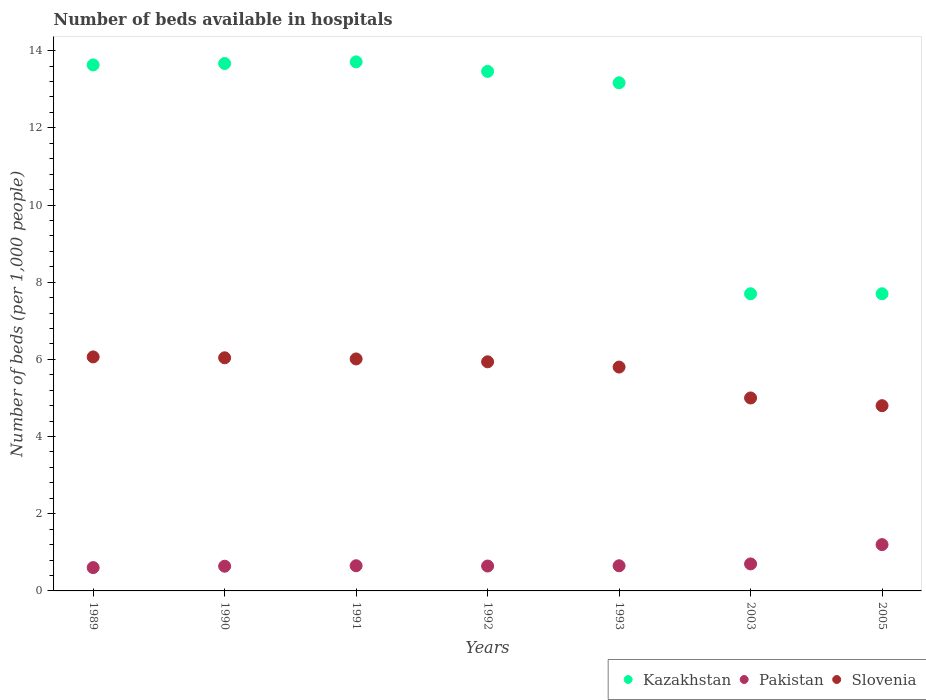How many different coloured dotlines are there?
Your answer should be very brief. 3. What is the number of beds in the hospiatls of in Slovenia in 1990?
Offer a terse response. 6.04. Across all years, what is the minimum number of beds in the hospiatls of in Pakistan?
Make the answer very short. 0.6. What is the total number of beds in the hospiatls of in Pakistan in the graph?
Offer a very short reply. 5.09. What is the difference between the number of beds in the hospiatls of in Pakistan in 1991 and that in 1993?
Your answer should be very brief. 0. What is the difference between the number of beds in the hospiatls of in Kazakhstan in 1993 and the number of beds in the hospiatls of in Pakistan in 2003?
Your answer should be compact. 12.47. What is the average number of beds in the hospiatls of in Slovenia per year?
Provide a short and direct response. 5.66. In the year 2005, what is the difference between the number of beds in the hospiatls of in Slovenia and number of beds in the hospiatls of in Kazakhstan?
Your response must be concise. -2.9. What is the ratio of the number of beds in the hospiatls of in Slovenia in 1990 to that in 1992?
Ensure brevity in your answer.  1.02. Is the difference between the number of beds in the hospiatls of in Slovenia in 1993 and 2005 greater than the difference between the number of beds in the hospiatls of in Kazakhstan in 1993 and 2005?
Ensure brevity in your answer.  No. What is the difference between the highest and the lowest number of beds in the hospiatls of in Slovenia?
Keep it short and to the point. 1.26. In how many years, is the number of beds in the hospiatls of in Kazakhstan greater than the average number of beds in the hospiatls of in Kazakhstan taken over all years?
Give a very brief answer. 5. Is it the case that in every year, the sum of the number of beds in the hospiatls of in Kazakhstan and number of beds in the hospiatls of in Pakistan  is greater than the number of beds in the hospiatls of in Slovenia?
Provide a succinct answer. Yes. Does the number of beds in the hospiatls of in Kazakhstan monotonically increase over the years?
Your answer should be compact. No. Is the number of beds in the hospiatls of in Kazakhstan strictly less than the number of beds in the hospiatls of in Pakistan over the years?
Your answer should be very brief. No. How many dotlines are there?
Offer a very short reply. 3. How many years are there in the graph?
Ensure brevity in your answer.  7. What is the difference between two consecutive major ticks on the Y-axis?
Offer a very short reply. 2. Are the values on the major ticks of Y-axis written in scientific E-notation?
Keep it short and to the point. No. Does the graph contain any zero values?
Your answer should be very brief. No. How are the legend labels stacked?
Make the answer very short. Horizontal. What is the title of the graph?
Make the answer very short. Number of beds available in hospitals. What is the label or title of the X-axis?
Offer a very short reply. Years. What is the label or title of the Y-axis?
Your answer should be very brief. Number of beds (per 1,0 people). What is the Number of beds (per 1,000 people) of Kazakhstan in 1989?
Provide a short and direct response. 13.63. What is the Number of beds (per 1,000 people) of Pakistan in 1989?
Your answer should be very brief. 0.6. What is the Number of beds (per 1,000 people) in Slovenia in 1989?
Provide a short and direct response. 6.06. What is the Number of beds (per 1,000 people) of Kazakhstan in 1990?
Give a very brief answer. 13.67. What is the Number of beds (per 1,000 people) of Pakistan in 1990?
Provide a succinct answer. 0.64. What is the Number of beds (per 1,000 people) of Slovenia in 1990?
Your answer should be very brief. 6.04. What is the Number of beds (per 1,000 people) in Kazakhstan in 1991?
Your answer should be very brief. 13.71. What is the Number of beds (per 1,000 people) of Pakistan in 1991?
Your answer should be very brief. 0.65. What is the Number of beds (per 1,000 people) in Slovenia in 1991?
Your answer should be very brief. 6.01. What is the Number of beds (per 1,000 people) in Kazakhstan in 1992?
Your response must be concise. 13.46. What is the Number of beds (per 1,000 people) in Pakistan in 1992?
Offer a very short reply. 0.64. What is the Number of beds (per 1,000 people) of Slovenia in 1992?
Keep it short and to the point. 5.94. What is the Number of beds (per 1,000 people) in Kazakhstan in 1993?
Provide a short and direct response. 13.17. What is the Number of beds (per 1,000 people) in Pakistan in 1993?
Your answer should be compact. 0.65. What is the Number of beds (per 1,000 people) in Slovenia in 1993?
Your answer should be compact. 5.8. What is the Number of beds (per 1,000 people) of Kazakhstan in 2003?
Your response must be concise. 7.7. Across all years, what is the maximum Number of beds (per 1,000 people) in Kazakhstan?
Offer a very short reply. 13.71. Across all years, what is the maximum Number of beds (per 1,000 people) in Slovenia?
Ensure brevity in your answer.  6.06. Across all years, what is the minimum Number of beds (per 1,000 people) of Kazakhstan?
Offer a terse response. 7.7. Across all years, what is the minimum Number of beds (per 1,000 people) of Pakistan?
Provide a short and direct response. 0.6. Across all years, what is the minimum Number of beds (per 1,000 people) in Slovenia?
Offer a terse response. 4.8. What is the total Number of beds (per 1,000 people) of Kazakhstan in the graph?
Keep it short and to the point. 83.03. What is the total Number of beds (per 1,000 people) of Pakistan in the graph?
Your answer should be compact. 5.09. What is the total Number of beds (per 1,000 people) of Slovenia in the graph?
Your answer should be very brief. 39.65. What is the difference between the Number of beds (per 1,000 people) in Kazakhstan in 1989 and that in 1990?
Keep it short and to the point. -0.04. What is the difference between the Number of beds (per 1,000 people) of Pakistan in 1989 and that in 1990?
Keep it short and to the point. -0.04. What is the difference between the Number of beds (per 1,000 people) of Slovenia in 1989 and that in 1990?
Provide a succinct answer. 0.02. What is the difference between the Number of beds (per 1,000 people) in Kazakhstan in 1989 and that in 1991?
Provide a succinct answer. -0.08. What is the difference between the Number of beds (per 1,000 people) in Pakistan in 1989 and that in 1991?
Provide a succinct answer. -0.05. What is the difference between the Number of beds (per 1,000 people) in Slovenia in 1989 and that in 1991?
Your answer should be very brief. 0.05. What is the difference between the Number of beds (per 1,000 people) of Kazakhstan in 1989 and that in 1992?
Offer a very short reply. 0.17. What is the difference between the Number of beds (per 1,000 people) in Pakistan in 1989 and that in 1992?
Your answer should be very brief. -0.04. What is the difference between the Number of beds (per 1,000 people) in Slovenia in 1989 and that in 1992?
Give a very brief answer. 0.13. What is the difference between the Number of beds (per 1,000 people) in Kazakhstan in 1989 and that in 1993?
Keep it short and to the point. 0.46. What is the difference between the Number of beds (per 1,000 people) of Pakistan in 1989 and that in 1993?
Your answer should be compact. -0.05. What is the difference between the Number of beds (per 1,000 people) of Slovenia in 1989 and that in 1993?
Provide a short and direct response. 0.26. What is the difference between the Number of beds (per 1,000 people) of Kazakhstan in 1989 and that in 2003?
Make the answer very short. 5.93. What is the difference between the Number of beds (per 1,000 people) in Pakistan in 1989 and that in 2003?
Offer a terse response. -0.1. What is the difference between the Number of beds (per 1,000 people) of Slovenia in 1989 and that in 2003?
Your answer should be compact. 1.06. What is the difference between the Number of beds (per 1,000 people) of Kazakhstan in 1989 and that in 2005?
Provide a succinct answer. 5.93. What is the difference between the Number of beds (per 1,000 people) in Pakistan in 1989 and that in 2005?
Your response must be concise. -0.6. What is the difference between the Number of beds (per 1,000 people) of Slovenia in 1989 and that in 2005?
Provide a succinct answer. 1.26. What is the difference between the Number of beds (per 1,000 people) of Kazakhstan in 1990 and that in 1991?
Make the answer very short. -0.04. What is the difference between the Number of beds (per 1,000 people) of Pakistan in 1990 and that in 1991?
Ensure brevity in your answer.  -0.01. What is the difference between the Number of beds (per 1,000 people) in Slovenia in 1990 and that in 1991?
Make the answer very short. 0.03. What is the difference between the Number of beds (per 1,000 people) in Kazakhstan in 1990 and that in 1992?
Keep it short and to the point. 0.2. What is the difference between the Number of beds (per 1,000 people) of Pakistan in 1990 and that in 1992?
Ensure brevity in your answer.  -0. What is the difference between the Number of beds (per 1,000 people) in Slovenia in 1990 and that in 1992?
Offer a terse response. 0.1. What is the difference between the Number of beds (per 1,000 people) of Kazakhstan in 1990 and that in 1993?
Offer a terse response. 0.5. What is the difference between the Number of beds (per 1,000 people) of Pakistan in 1990 and that in 1993?
Your answer should be very brief. -0.01. What is the difference between the Number of beds (per 1,000 people) of Slovenia in 1990 and that in 1993?
Offer a terse response. 0.24. What is the difference between the Number of beds (per 1,000 people) of Kazakhstan in 1990 and that in 2003?
Ensure brevity in your answer.  5.97. What is the difference between the Number of beds (per 1,000 people) of Pakistan in 1990 and that in 2003?
Your answer should be very brief. -0.06. What is the difference between the Number of beds (per 1,000 people) of Slovenia in 1990 and that in 2003?
Give a very brief answer. 1.04. What is the difference between the Number of beds (per 1,000 people) in Kazakhstan in 1990 and that in 2005?
Your answer should be very brief. 5.97. What is the difference between the Number of beds (per 1,000 people) in Pakistan in 1990 and that in 2005?
Your answer should be compact. -0.56. What is the difference between the Number of beds (per 1,000 people) in Slovenia in 1990 and that in 2005?
Give a very brief answer. 1.24. What is the difference between the Number of beds (per 1,000 people) in Kazakhstan in 1991 and that in 1992?
Offer a terse response. 0.25. What is the difference between the Number of beds (per 1,000 people) of Pakistan in 1991 and that in 1992?
Your answer should be very brief. 0.01. What is the difference between the Number of beds (per 1,000 people) in Slovenia in 1991 and that in 1992?
Make the answer very short. 0.07. What is the difference between the Number of beds (per 1,000 people) in Kazakhstan in 1991 and that in 1993?
Offer a very short reply. 0.54. What is the difference between the Number of beds (per 1,000 people) of Pakistan in 1991 and that in 1993?
Offer a very short reply. 0. What is the difference between the Number of beds (per 1,000 people) in Slovenia in 1991 and that in 1993?
Your answer should be compact. 0.21. What is the difference between the Number of beds (per 1,000 people) in Kazakhstan in 1991 and that in 2003?
Give a very brief answer. 6.01. What is the difference between the Number of beds (per 1,000 people) of Pakistan in 1991 and that in 2003?
Ensure brevity in your answer.  -0.05. What is the difference between the Number of beds (per 1,000 people) of Slovenia in 1991 and that in 2003?
Your response must be concise. 1.01. What is the difference between the Number of beds (per 1,000 people) of Kazakhstan in 1991 and that in 2005?
Provide a short and direct response. 6.01. What is the difference between the Number of beds (per 1,000 people) of Pakistan in 1991 and that in 2005?
Make the answer very short. -0.55. What is the difference between the Number of beds (per 1,000 people) in Slovenia in 1991 and that in 2005?
Ensure brevity in your answer.  1.21. What is the difference between the Number of beds (per 1,000 people) of Kazakhstan in 1992 and that in 1993?
Your answer should be very brief. 0.3. What is the difference between the Number of beds (per 1,000 people) of Pakistan in 1992 and that in 1993?
Ensure brevity in your answer.  -0.01. What is the difference between the Number of beds (per 1,000 people) of Slovenia in 1992 and that in 1993?
Ensure brevity in your answer.  0.14. What is the difference between the Number of beds (per 1,000 people) in Kazakhstan in 1992 and that in 2003?
Offer a terse response. 5.76. What is the difference between the Number of beds (per 1,000 people) in Pakistan in 1992 and that in 2003?
Give a very brief answer. -0.06. What is the difference between the Number of beds (per 1,000 people) of Slovenia in 1992 and that in 2003?
Offer a terse response. 0.94. What is the difference between the Number of beds (per 1,000 people) in Kazakhstan in 1992 and that in 2005?
Provide a succinct answer. 5.76. What is the difference between the Number of beds (per 1,000 people) of Pakistan in 1992 and that in 2005?
Your answer should be compact. -0.56. What is the difference between the Number of beds (per 1,000 people) of Slovenia in 1992 and that in 2005?
Offer a very short reply. 1.14. What is the difference between the Number of beds (per 1,000 people) in Kazakhstan in 1993 and that in 2003?
Your answer should be compact. 5.47. What is the difference between the Number of beds (per 1,000 people) of Pakistan in 1993 and that in 2003?
Your response must be concise. -0.05. What is the difference between the Number of beds (per 1,000 people) in Slovenia in 1993 and that in 2003?
Make the answer very short. 0.8. What is the difference between the Number of beds (per 1,000 people) of Kazakhstan in 1993 and that in 2005?
Offer a terse response. 5.47. What is the difference between the Number of beds (per 1,000 people) in Pakistan in 1993 and that in 2005?
Give a very brief answer. -0.55. What is the difference between the Number of beds (per 1,000 people) of Slovenia in 1993 and that in 2005?
Offer a very short reply. 1. What is the difference between the Number of beds (per 1,000 people) in Kazakhstan in 2003 and that in 2005?
Provide a short and direct response. -0. What is the difference between the Number of beds (per 1,000 people) of Pakistan in 2003 and that in 2005?
Provide a succinct answer. -0.5. What is the difference between the Number of beds (per 1,000 people) in Kazakhstan in 1989 and the Number of beds (per 1,000 people) in Pakistan in 1990?
Provide a succinct answer. 12.99. What is the difference between the Number of beds (per 1,000 people) in Kazakhstan in 1989 and the Number of beds (per 1,000 people) in Slovenia in 1990?
Offer a very short reply. 7.59. What is the difference between the Number of beds (per 1,000 people) in Pakistan in 1989 and the Number of beds (per 1,000 people) in Slovenia in 1990?
Provide a short and direct response. -5.44. What is the difference between the Number of beds (per 1,000 people) of Kazakhstan in 1989 and the Number of beds (per 1,000 people) of Pakistan in 1991?
Your answer should be compact. 12.98. What is the difference between the Number of beds (per 1,000 people) in Kazakhstan in 1989 and the Number of beds (per 1,000 people) in Slovenia in 1991?
Provide a short and direct response. 7.62. What is the difference between the Number of beds (per 1,000 people) in Pakistan in 1989 and the Number of beds (per 1,000 people) in Slovenia in 1991?
Offer a very short reply. -5.41. What is the difference between the Number of beds (per 1,000 people) in Kazakhstan in 1989 and the Number of beds (per 1,000 people) in Pakistan in 1992?
Your response must be concise. 12.99. What is the difference between the Number of beds (per 1,000 people) in Kazakhstan in 1989 and the Number of beds (per 1,000 people) in Slovenia in 1992?
Keep it short and to the point. 7.69. What is the difference between the Number of beds (per 1,000 people) of Pakistan in 1989 and the Number of beds (per 1,000 people) of Slovenia in 1992?
Make the answer very short. -5.33. What is the difference between the Number of beds (per 1,000 people) of Kazakhstan in 1989 and the Number of beds (per 1,000 people) of Pakistan in 1993?
Your response must be concise. 12.98. What is the difference between the Number of beds (per 1,000 people) in Kazakhstan in 1989 and the Number of beds (per 1,000 people) in Slovenia in 1993?
Your answer should be compact. 7.83. What is the difference between the Number of beds (per 1,000 people) of Pakistan in 1989 and the Number of beds (per 1,000 people) of Slovenia in 1993?
Provide a short and direct response. -5.2. What is the difference between the Number of beds (per 1,000 people) in Kazakhstan in 1989 and the Number of beds (per 1,000 people) in Pakistan in 2003?
Your response must be concise. 12.93. What is the difference between the Number of beds (per 1,000 people) in Kazakhstan in 1989 and the Number of beds (per 1,000 people) in Slovenia in 2003?
Your response must be concise. 8.63. What is the difference between the Number of beds (per 1,000 people) of Pakistan in 1989 and the Number of beds (per 1,000 people) of Slovenia in 2003?
Provide a succinct answer. -4.4. What is the difference between the Number of beds (per 1,000 people) of Kazakhstan in 1989 and the Number of beds (per 1,000 people) of Pakistan in 2005?
Your response must be concise. 12.43. What is the difference between the Number of beds (per 1,000 people) in Kazakhstan in 1989 and the Number of beds (per 1,000 people) in Slovenia in 2005?
Offer a terse response. 8.83. What is the difference between the Number of beds (per 1,000 people) of Pakistan in 1989 and the Number of beds (per 1,000 people) of Slovenia in 2005?
Your answer should be compact. -4.2. What is the difference between the Number of beds (per 1,000 people) in Kazakhstan in 1990 and the Number of beds (per 1,000 people) in Pakistan in 1991?
Keep it short and to the point. 13.01. What is the difference between the Number of beds (per 1,000 people) in Kazakhstan in 1990 and the Number of beds (per 1,000 people) in Slovenia in 1991?
Provide a succinct answer. 7.65. What is the difference between the Number of beds (per 1,000 people) of Pakistan in 1990 and the Number of beds (per 1,000 people) of Slovenia in 1991?
Offer a terse response. -5.37. What is the difference between the Number of beds (per 1,000 people) of Kazakhstan in 1990 and the Number of beds (per 1,000 people) of Pakistan in 1992?
Keep it short and to the point. 13.02. What is the difference between the Number of beds (per 1,000 people) in Kazakhstan in 1990 and the Number of beds (per 1,000 people) in Slovenia in 1992?
Ensure brevity in your answer.  7.73. What is the difference between the Number of beds (per 1,000 people) in Pakistan in 1990 and the Number of beds (per 1,000 people) in Slovenia in 1992?
Your answer should be very brief. -5.3. What is the difference between the Number of beds (per 1,000 people) of Kazakhstan in 1990 and the Number of beds (per 1,000 people) of Pakistan in 1993?
Provide a short and direct response. 13.01. What is the difference between the Number of beds (per 1,000 people) in Kazakhstan in 1990 and the Number of beds (per 1,000 people) in Slovenia in 1993?
Keep it short and to the point. 7.87. What is the difference between the Number of beds (per 1,000 people) in Pakistan in 1990 and the Number of beds (per 1,000 people) in Slovenia in 1993?
Your answer should be very brief. -5.16. What is the difference between the Number of beds (per 1,000 people) in Kazakhstan in 1990 and the Number of beds (per 1,000 people) in Pakistan in 2003?
Your response must be concise. 12.97. What is the difference between the Number of beds (per 1,000 people) of Kazakhstan in 1990 and the Number of beds (per 1,000 people) of Slovenia in 2003?
Offer a terse response. 8.67. What is the difference between the Number of beds (per 1,000 people) of Pakistan in 1990 and the Number of beds (per 1,000 people) of Slovenia in 2003?
Your response must be concise. -4.36. What is the difference between the Number of beds (per 1,000 people) in Kazakhstan in 1990 and the Number of beds (per 1,000 people) in Pakistan in 2005?
Give a very brief answer. 12.47. What is the difference between the Number of beds (per 1,000 people) in Kazakhstan in 1990 and the Number of beds (per 1,000 people) in Slovenia in 2005?
Make the answer very short. 8.87. What is the difference between the Number of beds (per 1,000 people) in Pakistan in 1990 and the Number of beds (per 1,000 people) in Slovenia in 2005?
Provide a short and direct response. -4.16. What is the difference between the Number of beds (per 1,000 people) of Kazakhstan in 1991 and the Number of beds (per 1,000 people) of Pakistan in 1992?
Provide a succinct answer. 13.06. What is the difference between the Number of beds (per 1,000 people) of Kazakhstan in 1991 and the Number of beds (per 1,000 people) of Slovenia in 1992?
Your answer should be compact. 7.77. What is the difference between the Number of beds (per 1,000 people) in Pakistan in 1991 and the Number of beds (per 1,000 people) in Slovenia in 1992?
Make the answer very short. -5.28. What is the difference between the Number of beds (per 1,000 people) of Kazakhstan in 1991 and the Number of beds (per 1,000 people) of Pakistan in 1993?
Provide a short and direct response. 13.06. What is the difference between the Number of beds (per 1,000 people) in Kazakhstan in 1991 and the Number of beds (per 1,000 people) in Slovenia in 1993?
Ensure brevity in your answer.  7.91. What is the difference between the Number of beds (per 1,000 people) in Pakistan in 1991 and the Number of beds (per 1,000 people) in Slovenia in 1993?
Your answer should be very brief. -5.15. What is the difference between the Number of beds (per 1,000 people) in Kazakhstan in 1991 and the Number of beds (per 1,000 people) in Pakistan in 2003?
Your answer should be compact. 13.01. What is the difference between the Number of beds (per 1,000 people) in Kazakhstan in 1991 and the Number of beds (per 1,000 people) in Slovenia in 2003?
Give a very brief answer. 8.71. What is the difference between the Number of beds (per 1,000 people) of Pakistan in 1991 and the Number of beds (per 1,000 people) of Slovenia in 2003?
Keep it short and to the point. -4.35. What is the difference between the Number of beds (per 1,000 people) of Kazakhstan in 1991 and the Number of beds (per 1,000 people) of Pakistan in 2005?
Offer a terse response. 12.51. What is the difference between the Number of beds (per 1,000 people) of Kazakhstan in 1991 and the Number of beds (per 1,000 people) of Slovenia in 2005?
Your response must be concise. 8.91. What is the difference between the Number of beds (per 1,000 people) in Pakistan in 1991 and the Number of beds (per 1,000 people) in Slovenia in 2005?
Keep it short and to the point. -4.15. What is the difference between the Number of beds (per 1,000 people) in Kazakhstan in 1992 and the Number of beds (per 1,000 people) in Pakistan in 1993?
Ensure brevity in your answer.  12.81. What is the difference between the Number of beds (per 1,000 people) of Kazakhstan in 1992 and the Number of beds (per 1,000 people) of Slovenia in 1993?
Offer a terse response. 7.66. What is the difference between the Number of beds (per 1,000 people) of Pakistan in 1992 and the Number of beds (per 1,000 people) of Slovenia in 1993?
Ensure brevity in your answer.  -5.16. What is the difference between the Number of beds (per 1,000 people) in Kazakhstan in 1992 and the Number of beds (per 1,000 people) in Pakistan in 2003?
Provide a succinct answer. 12.76. What is the difference between the Number of beds (per 1,000 people) of Kazakhstan in 1992 and the Number of beds (per 1,000 people) of Slovenia in 2003?
Give a very brief answer. 8.46. What is the difference between the Number of beds (per 1,000 people) in Pakistan in 1992 and the Number of beds (per 1,000 people) in Slovenia in 2003?
Give a very brief answer. -4.36. What is the difference between the Number of beds (per 1,000 people) in Kazakhstan in 1992 and the Number of beds (per 1,000 people) in Pakistan in 2005?
Your answer should be very brief. 12.26. What is the difference between the Number of beds (per 1,000 people) in Kazakhstan in 1992 and the Number of beds (per 1,000 people) in Slovenia in 2005?
Offer a very short reply. 8.66. What is the difference between the Number of beds (per 1,000 people) of Pakistan in 1992 and the Number of beds (per 1,000 people) of Slovenia in 2005?
Give a very brief answer. -4.16. What is the difference between the Number of beds (per 1,000 people) of Kazakhstan in 1993 and the Number of beds (per 1,000 people) of Pakistan in 2003?
Provide a short and direct response. 12.47. What is the difference between the Number of beds (per 1,000 people) in Kazakhstan in 1993 and the Number of beds (per 1,000 people) in Slovenia in 2003?
Your answer should be compact. 8.17. What is the difference between the Number of beds (per 1,000 people) of Pakistan in 1993 and the Number of beds (per 1,000 people) of Slovenia in 2003?
Give a very brief answer. -4.35. What is the difference between the Number of beds (per 1,000 people) in Kazakhstan in 1993 and the Number of beds (per 1,000 people) in Pakistan in 2005?
Make the answer very short. 11.97. What is the difference between the Number of beds (per 1,000 people) in Kazakhstan in 1993 and the Number of beds (per 1,000 people) in Slovenia in 2005?
Provide a succinct answer. 8.37. What is the difference between the Number of beds (per 1,000 people) of Pakistan in 1993 and the Number of beds (per 1,000 people) of Slovenia in 2005?
Your answer should be compact. -4.15. What is the difference between the Number of beds (per 1,000 people) of Kazakhstan in 2003 and the Number of beds (per 1,000 people) of Pakistan in 2005?
Provide a succinct answer. 6.5. What is the average Number of beds (per 1,000 people) of Kazakhstan per year?
Provide a succinct answer. 11.86. What is the average Number of beds (per 1,000 people) in Pakistan per year?
Keep it short and to the point. 0.73. What is the average Number of beds (per 1,000 people) of Slovenia per year?
Offer a very short reply. 5.66. In the year 1989, what is the difference between the Number of beds (per 1,000 people) in Kazakhstan and Number of beds (per 1,000 people) in Pakistan?
Your answer should be compact. 13.03. In the year 1989, what is the difference between the Number of beds (per 1,000 people) in Kazakhstan and Number of beds (per 1,000 people) in Slovenia?
Offer a terse response. 7.57. In the year 1989, what is the difference between the Number of beds (per 1,000 people) in Pakistan and Number of beds (per 1,000 people) in Slovenia?
Offer a very short reply. -5.46. In the year 1990, what is the difference between the Number of beds (per 1,000 people) of Kazakhstan and Number of beds (per 1,000 people) of Pakistan?
Keep it short and to the point. 13.03. In the year 1990, what is the difference between the Number of beds (per 1,000 people) in Kazakhstan and Number of beds (per 1,000 people) in Slovenia?
Offer a terse response. 7.63. In the year 1990, what is the difference between the Number of beds (per 1,000 people) of Pakistan and Number of beds (per 1,000 people) of Slovenia?
Give a very brief answer. -5.4. In the year 1991, what is the difference between the Number of beds (per 1,000 people) in Kazakhstan and Number of beds (per 1,000 people) in Pakistan?
Give a very brief answer. 13.06. In the year 1991, what is the difference between the Number of beds (per 1,000 people) of Kazakhstan and Number of beds (per 1,000 people) of Slovenia?
Give a very brief answer. 7.7. In the year 1991, what is the difference between the Number of beds (per 1,000 people) of Pakistan and Number of beds (per 1,000 people) of Slovenia?
Make the answer very short. -5.36. In the year 1992, what is the difference between the Number of beds (per 1,000 people) of Kazakhstan and Number of beds (per 1,000 people) of Pakistan?
Offer a terse response. 12.82. In the year 1992, what is the difference between the Number of beds (per 1,000 people) of Kazakhstan and Number of beds (per 1,000 people) of Slovenia?
Give a very brief answer. 7.52. In the year 1992, what is the difference between the Number of beds (per 1,000 people) of Pakistan and Number of beds (per 1,000 people) of Slovenia?
Ensure brevity in your answer.  -5.29. In the year 1993, what is the difference between the Number of beds (per 1,000 people) in Kazakhstan and Number of beds (per 1,000 people) in Pakistan?
Keep it short and to the point. 12.52. In the year 1993, what is the difference between the Number of beds (per 1,000 people) of Kazakhstan and Number of beds (per 1,000 people) of Slovenia?
Ensure brevity in your answer.  7.37. In the year 1993, what is the difference between the Number of beds (per 1,000 people) in Pakistan and Number of beds (per 1,000 people) in Slovenia?
Your answer should be very brief. -5.15. In the year 2005, what is the difference between the Number of beds (per 1,000 people) of Kazakhstan and Number of beds (per 1,000 people) of Pakistan?
Ensure brevity in your answer.  6.5. In the year 2005, what is the difference between the Number of beds (per 1,000 people) of Kazakhstan and Number of beds (per 1,000 people) of Slovenia?
Ensure brevity in your answer.  2.9. In the year 2005, what is the difference between the Number of beds (per 1,000 people) of Pakistan and Number of beds (per 1,000 people) of Slovenia?
Give a very brief answer. -3.6. What is the ratio of the Number of beds (per 1,000 people) in Kazakhstan in 1989 to that in 1990?
Ensure brevity in your answer.  1. What is the ratio of the Number of beds (per 1,000 people) in Pakistan in 1989 to that in 1990?
Offer a very short reply. 0.94. What is the ratio of the Number of beds (per 1,000 people) in Pakistan in 1989 to that in 1991?
Keep it short and to the point. 0.93. What is the ratio of the Number of beds (per 1,000 people) in Slovenia in 1989 to that in 1991?
Your response must be concise. 1.01. What is the ratio of the Number of beds (per 1,000 people) of Kazakhstan in 1989 to that in 1992?
Your response must be concise. 1.01. What is the ratio of the Number of beds (per 1,000 people) in Pakistan in 1989 to that in 1992?
Your answer should be compact. 0.94. What is the ratio of the Number of beds (per 1,000 people) of Slovenia in 1989 to that in 1992?
Ensure brevity in your answer.  1.02. What is the ratio of the Number of beds (per 1,000 people) of Kazakhstan in 1989 to that in 1993?
Offer a very short reply. 1.04. What is the ratio of the Number of beds (per 1,000 people) of Pakistan in 1989 to that in 1993?
Provide a short and direct response. 0.93. What is the ratio of the Number of beds (per 1,000 people) of Slovenia in 1989 to that in 1993?
Give a very brief answer. 1.05. What is the ratio of the Number of beds (per 1,000 people) of Kazakhstan in 1989 to that in 2003?
Provide a short and direct response. 1.77. What is the ratio of the Number of beds (per 1,000 people) in Pakistan in 1989 to that in 2003?
Ensure brevity in your answer.  0.86. What is the ratio of the Number of beds (per 1,000 people) of Slovenia in 1989 to that in 2003?
Your answer should be very brief. 1.21. What is the ratio of the Number of beds (per 1,000 people) in Kazakhstan in 1989 to that in 2005?
Keep it short and to the point. 1.77. What is the ratio of the Number of beds (per 1,000 people) in Pakistan in 1989 to that in 2005?
Offer a very short reply. 0.5. What is the ratio of the Number of beds (per 1,000 people) of Slovenia in 1989 to that in 2005?
Ensure brevity in your answer.  1.26. What is the ratio of the Number of beds (per 1,000 people) of Pakistan in 1990 to that in 1991?
Offer a very short reply. 0.98. What is the ratio of the Number of beds (per 1,000 people) of Kazakhstan in 1990 to that in 1992?
Your answer should be very brief. 1.02. What is the ratio of the Number of beds (per 1,000 people) in Pakistan in 1990 to that in 1992?
Give a very brief answer. 0.99. What is the ratio of the Number of beds (per 1,000 people) of Slovenia in 1990 to that in 1992?
Your answer should be compact. 1.02. What is the ratio of the Number of beds (per 1,000 people) in Kazakhstan in 1990 to that in 1993?
Your answer should be compact. 1.04. What is the ratio of the Number of beds (per 1,000 people) in Pakistan in 1990 to that in 1993?
Provide a short and direct response. 0.98. What is the ratio of the Number of beds (per 1,000 people) of Slovenia in 1990 to that in 1993?
Keep it short and to the point. 1.04. What is the ratio of the Number of beds (per 1,000 people) in Kazakhstan in 1990 to that in 2003?
Give a very brief answer. 1.77. What is the ratio of the Number of beds (per 1,000 people) of Pakistan in 1990 to that in 2003?
Make the answer very short. 0.91. What is the ratio of the Number of beds (per 1,000 people) of Slovenia in 1990 to that in 2003?
Provide a succinct answer. 1.21. What is the ratio of the Number of beds (per 1,000 people) of Kazakhstan in 1990 to that in 2005?
Make the answer very short. 1.77. What is the ratio of the Number of beds (per 1,000 people) of Pakistan in 1990 to that in 2005?
Ensure brevity in your answer.  0.53. What is the ratio of the Number of beds (per 1,000 people) in Slovenia in 1990 to that in 2005?
Provide a short and direct response. 1.26. What is the ratio of the Number of beds (per 1,000 people) in Kazakhstan in 1991 to that in 1992?
Give a very brief answer. 1.02. What is the ratio of the Number of beds (per 1,000 people) of Pakistan in 1991 to that in 1992?
Provide a succinct answer. 1.01. What is the ratio of the Number of beds (per 1,000 people) of Slovenia in 1991 to that in 1992?
Offer a very short reply. 1.01. What is the ratio of the Number of beds (per 1,000 people) of Kazakhstan in 1991 to that in 1993?
Offer a very short reply. 1.04. What is the ratio of the Number of beds (per 1,000 people) in Pakistan in 1991 to that in 1993?
Provide a short and direct response. 1. What is the ratio of the Number of beds (per 1,000 people) of Slovenia in 1991 to that in 1993?
Provide a succinct answer. 1.04. What is the ratio of the Number of beds (per 1,000 people) of Kazakhstan in 1991 to that in 2003?
Your answer should be compact. 1.78. What is the ratio of the Number of beds (per 1,000 people) of Pakistan in 1991 to that in 2003?
Your answer should be compact. 0.93. What is the ratio of the Number of beds (per 1,000 people) of Slovenia in 1991 to that in 2003?
Keep it short and to the point. 1.2. What is the ratio of the Number of beds (per 1,000 people) of Kazakhstan in 1991 to that in 2005?
Your response must be concise. 1.78. What is the ratio of the Number of beds (per 1,000 people) of Pakistan in 1991 to that in 2005?
Give a very brief answer. 0.54. What is the ratio of the Number of beds (per 1,000 people) in Slovenia in 1991 to that in 2005?
Offer a very short reply. 1.25. What is the ratio of the Number of beds (per 1,000 people) in Kazakhstan in 1992 to that in 1993?
Provide a short and direct response. 1.02. What is the ratio of the Number of beds (per 1,000 people) in Slovenia in 1992 to that in 1993?
Provide a short and direct response. 1.02. What is the ratio of the Number of beds (per 1,000 people) of Kazakhstan in 1992 to that in 2003?
Offer a very short reply. 1.75. What is the ratio of the Number of beds (per 1,000 people) in Pakistan in 1992 to that in 2003?
Your answer should be very brief. 0.92. What is the ratio of the Number of beds (per 1,000 people) in Slovenia in 1992 to that in 2003?
Provide a succinct answer. 1.19. What is the ratio of the Number of beds (per 1,000 people) in Kazakhstan in 1992 to that in 2005?
Your response must be concise. 1.75. What is the ratio of the Number of beds (per 1,000 people) of Pakistan in 1992 to that in 2005?
Ensure brevity in your answer.  0.54. What is the ratio of the Number of beds (per 1,000 people) of Slovenia in 1992 to that in 2005?
Make the answer very short. 1.24. What is the ratio of the Number of beds (per 1,000 people) in Kazakhstan in 1993 to that in 2003?
Offer a terse response. 1.71. What is the ratio of the Number of beds (per 1,000 people) of Pakistan in 1993 to that in 2003?
Your answer should be very brief. 0.93. What is the ratio of the Number of beds (per 1,000 people) in Slovenia in 1993 to that in 2003?
Your answer should be compact. 1.16. What is the ratio of the Number of beds (per 1,000 people) in Kazakhstan in 1993 to that in 2005?
Your answer should be compact. 1.71. What is the ratio of the Number of beds (per 1,000 people) of Pakistan in 1993 to that in 2005?
Make the answer very short. 0.54. What is the ratio of the Number of beds (per 1,000 people) of Slovenia in 1993 to that in 2005?
Your answer should be very brief. 1.21. What is the ratio of the Number of beds (per 1,000 people) in Pakistan in 2003 to that in 2005?
Provide a short and direct response. 0.58. What is the ratio of the Number of beds (per 1,000 people) in Slovenia in 2003 to that in 2005?
Your answer should be compact. 1.04. What is the difference between the highest and the second highest Number of beds (per 1,000 people) of Kazakhstan?
Your answer should be compact. 0.04. What is the difference between the highest and the second highest Number of beds (per 1,000 people) of Slovenia?
Offer a terse response. 0.02. What is the difference between the highest and the lowest Number of beds (per 1,000 people) of Kazakhstan?
Your response must be concise. 6.01. What is the difference between the highest and the lowest Number of beds (per 1,000 people) of Pakistan?
Offer a very short reply. 0.6. What is the difference between the highest and the lowest Number of beds (per 1,000 people) in Slovenia?
Ensure brevity in your answer.  1.26. 